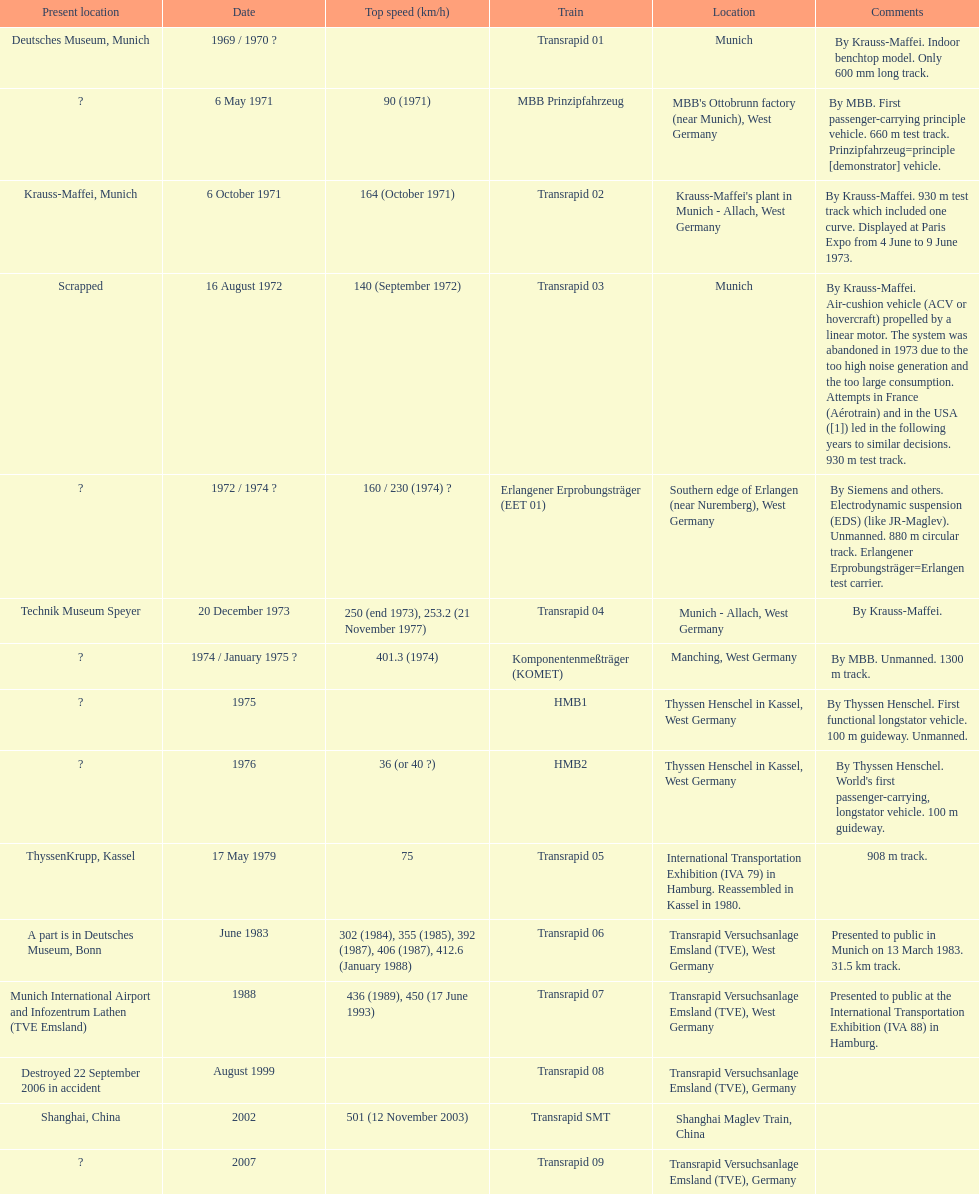What is the number of trains that were either scrapped or destroyed? 2. 